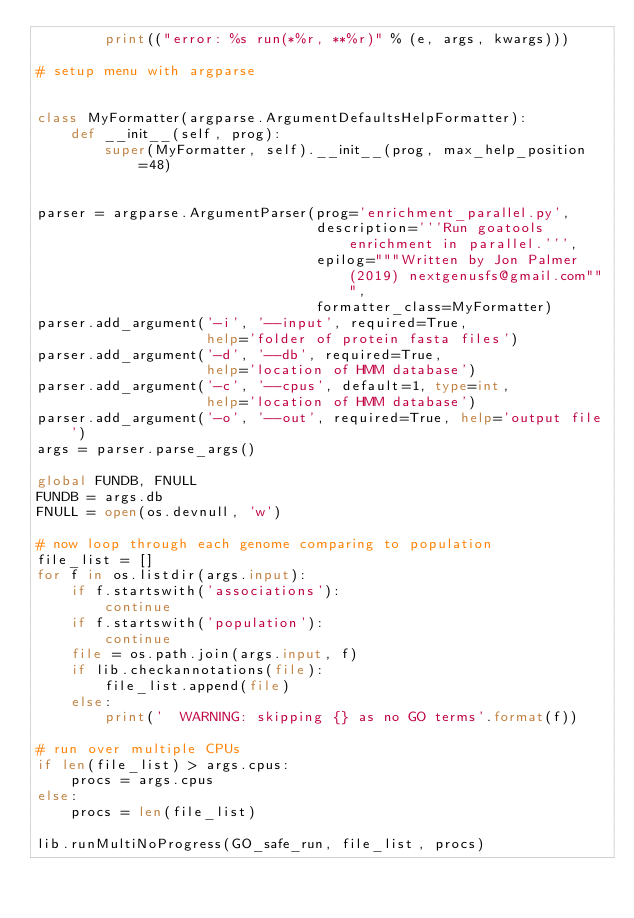<code> <loc_0><loc_0><loc_500><loc_500><_Python_>        print(("error: %s run(*%r, **%r)" % (e, args, kwargs)))

# setup menu with argparse


class MyFormatter(argparse.ArgumentDefaultsHelpFormatter):
    def __init__(self, prog):
        super(MyFormatter, self).__init__(prog, max_help_position=48)


parser = argparse.ArgumentParser(prog='enrichment_parallel.py',
                                 description='''Run goatools enrichment in parallel.''',
                                 epilog="""Written by Jon Palmer (2019) nextgenusfs@gmail.com""",
                                 formatter_class=MyFormatter)
parser.add_argument('-i', '--input', required=True,
                    help='folder of protein fasta files')
parser.add_argument('-d', '--db', required=True,
                    help='location of HMM database')
parser.add_argument('-c', '--cpus', default=1, type=int,
                    help='location of HMM database')
parser.add_argument('-o', '--out', required=True, help='output file')
args = parser.parse_args()

global FUNDB, FNULL
FUNDB = args.db
FNULL = open(os.devnull, 'w')

# now loop through each genome comparing to population
file_list = []
for f in os.listdir(args.input):
    if f.startswith('associations'):
        continue
    if f.startswith('population'):
        continue
    file = os.path.join(args.input, f)
    if lib.checkannotations(file):
        file_list.append(file)
    else:
        print('  WARNING: skipping {} as no GO terms'.format(f))

# run over multiple CPUs
if len(file_list) > args.cpus:
    procs = args.cpus
else:
    procs = len(file_list)

lib.runMultiNoProgress(GO_safe_run, file_list, procs)
</code> 